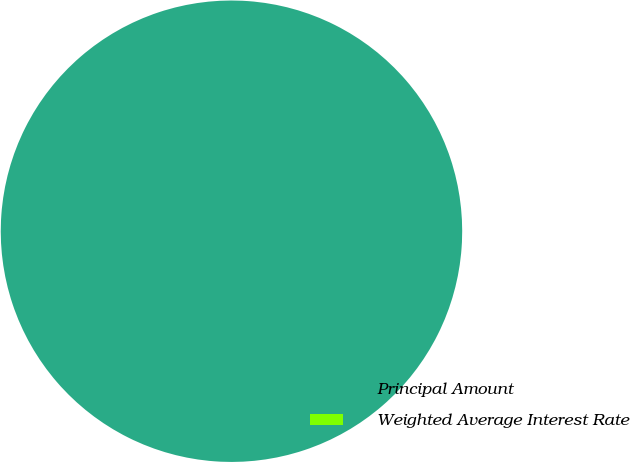<chart> <loc_0><loc_0><loc_500><loc_500><pie_chart><fcel>Principal Amount<fcel>Weighted Average Interest Rate<nl><fcel>100.0%<fcel>0.0%<nl></chart> 